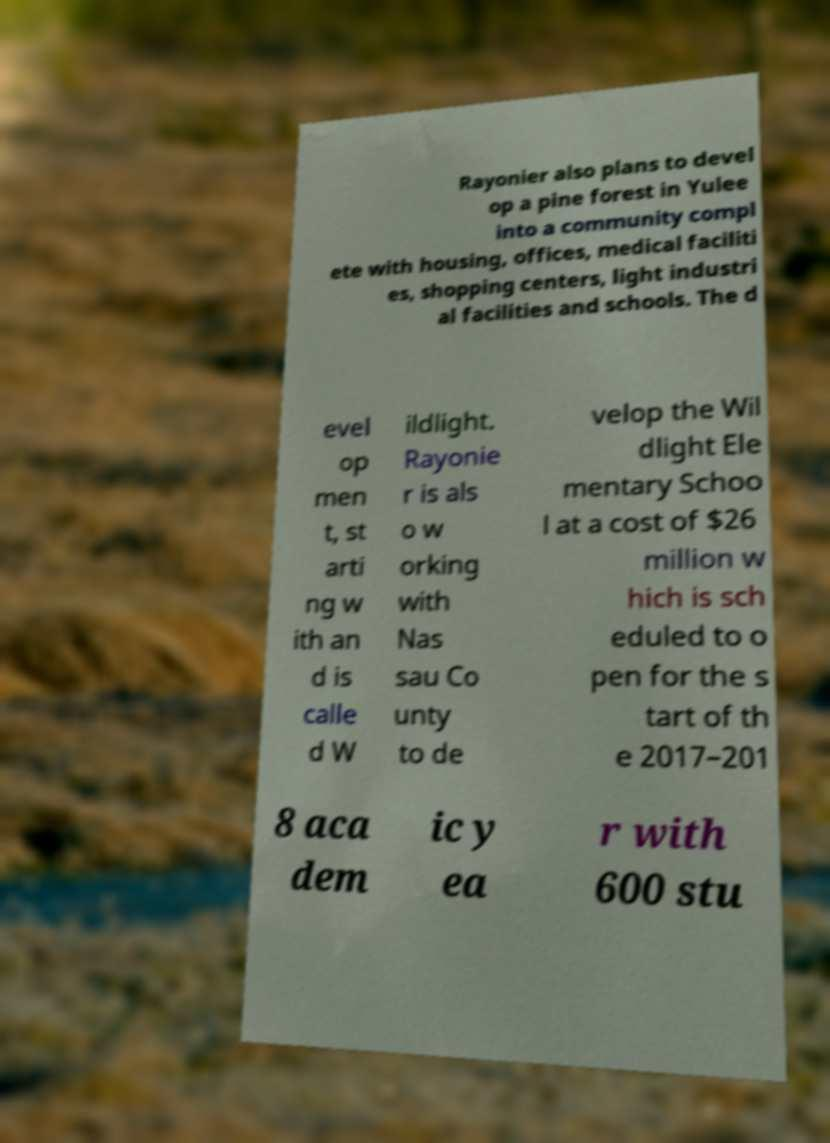For documentation purposes, I need the text within this image transcribed. Could you provide that? Rayonier also plans to devel op a pine forest in Yulee into a community compl ete with housing, offices, medical faciliti es, shopping centers, light industri al facilities and schools. The d evel op men t, st arti ng w ith an d is calle d W ildlight. Rayonie r is als o w orking with Nas sau Co unty to de velop the Wil dlight Ele mentary Schoo l at a cost of $26 million w hich is sch eduled to o pen for the s tart of th e 2017–201 8 aca dem ic y ea r with 600 stu 